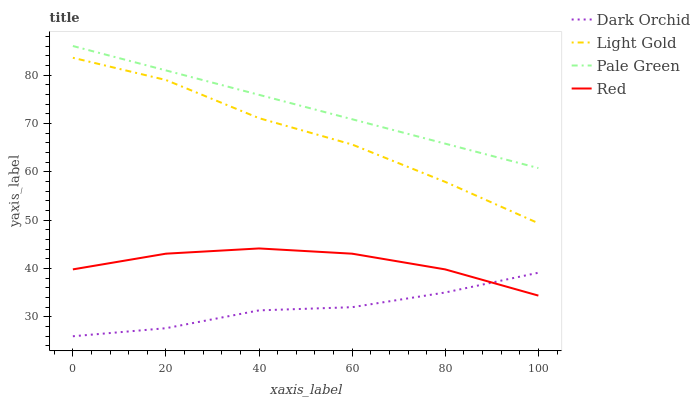Does Dark Orchid have the minimum area under the curve?
Answer yes or no. Yes. Does Pale Green have the maximum area under the curve?
Answer yes or no. Yes. Does Light Gold have the minimum area under the curve?
Answer yes or no. No. Does Light Gold have the maximum area under the curve?
Answer yes or no. No. Is Pale Green the smoothest?
Answer yes or no. Yes. Is Light Gold the roughest?
Answer yes or no. Yes. Is Red the smoothest?
Answer yes or no. No. Is Red the roughest?
Answer yes or no. No. Does Light Gold have the lowest value?
Answer yes or no. No. Does Pale Green have the highest value?
Answer yes or no. Yes. Does Light Gold have the highest value?
Answer yes or no. No. Is Red less than Light Gold?
Answer yes or no. Yes. Is Light Gold greater than Red?
Answer yes or no. Yes. Does Red intersect Dark Orchid?
Answer yes or no. Yes. Is Red less than Dark Orchid?
Answer yes or no. No. Is Red greater than Dark Orchid?
Answer yes or no. No. Does Red intersect Light Gold?
Answer yes or no. No. 